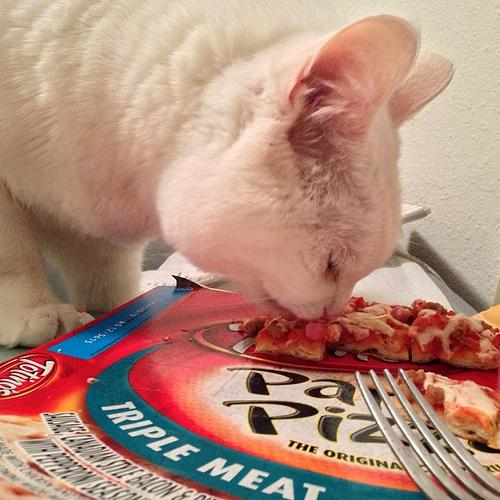Provide a succinct description of the most prominent aspect and its action in the illustration. White cat consuming a piece of pizza loaded with various meats atop a cardboard box. Explain the focal point of the image and the undertaking they are engaged in. The spotlight is on a white cat that savors a triple meat pizza slice positioned on its packaging. Describe the key figure of the image and the activity they are involved in. The image showcases a white cat relishing a slice of triple meat pizza from its box. Illustrate the image's core character and the task they are accomplishing. A white adult cat is captured eating a slice of Totinos triple meat party pizza from the box. Give a brief account of the primary item and the role it plays in the visual. The dominant visual element, a white cat, is feasting on a slice of pizza full of meat toppings. Mention the principal character and the deed they're performing in the photograph. A white feline is depicted relishing a slice of party pizza with meat toppings on a cardboard pizza box. Elaborate on the principal subject and their performance in the picture. The main focus in the image is a white cat delighting in a portion of meaty pizza placed on its box. Summarize the central element and its engagement in the scene. A white feline enjoys a slice of meaty pizza on the box it was served in. Narrate the main entity in the image and its corresponding action. In the image, a white cat can be seen indulging in a slice of pizza laden with meat toppings on the box. Identify the primary object and its activity in the image. A white cat is eating a slice of Totinos triple meat party pizza on a box. 